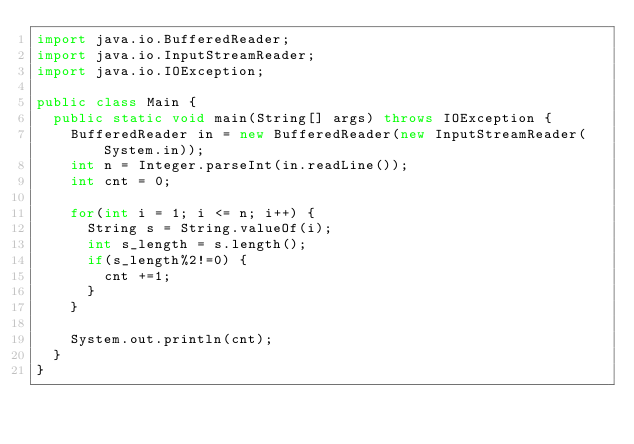Convert code to text. <code><loc_0><loc_0><loc_500><loc_500><_Java_>import java.io.BufferedReader;
import java.io.InputStreamReader;
import java.io.IOException;

public class Main {
  public static void main(String[] args) throws IOException {
    BufferedReader in = new BufferedReader(new InputStreamReader(System.in));
    int n = Integer.parseInt(in.readLine());
    int cnt = 0;

    for(int i = 1; i <= n; i++) {
      String s = String.valueOf(i);
      int s_length = s.length();
      if(s_length%2!=0) {
        cnt +=1;
      }
    }
    
    System.out.println(cnt);
  }
}</code> 